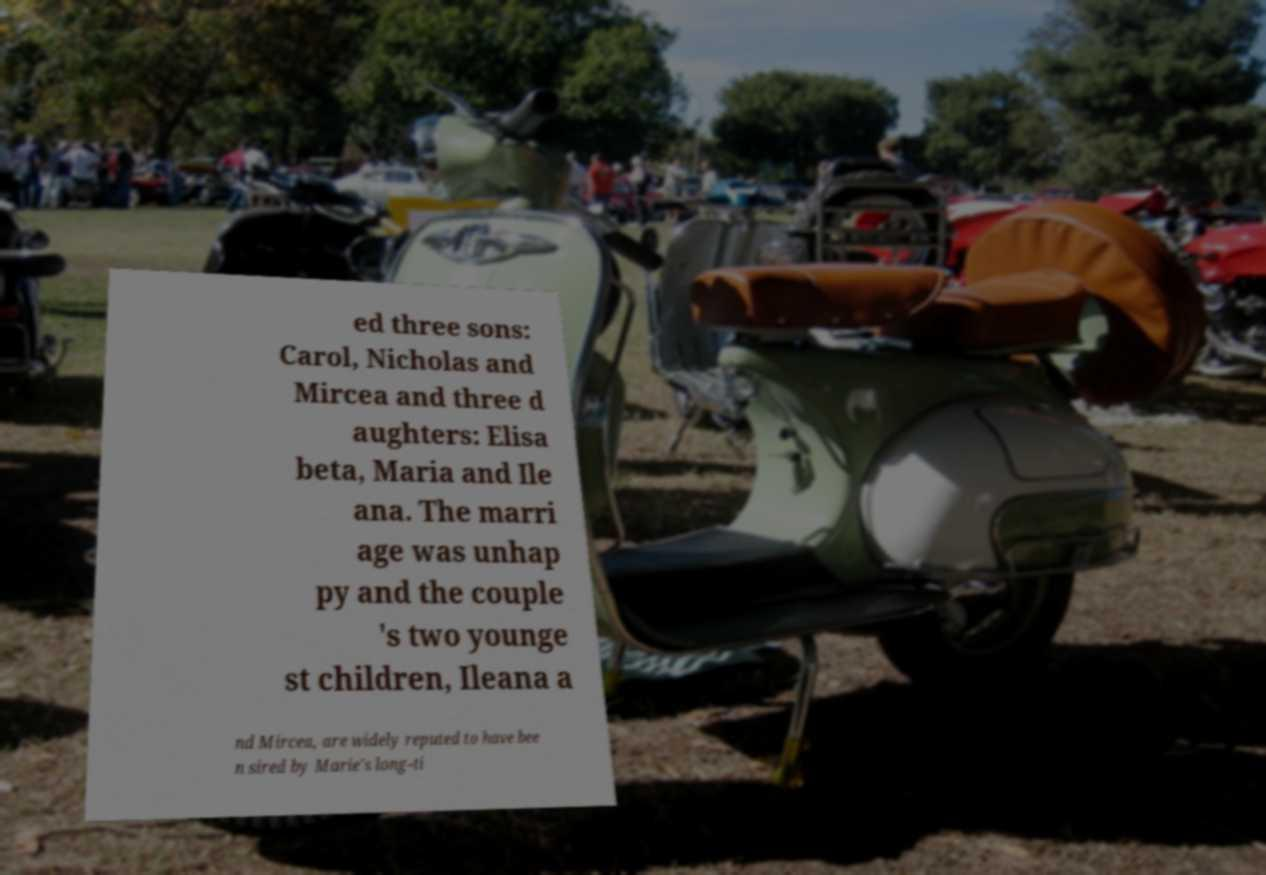Can you accurately transcribe the text from the provided image for me? ed three sons: Carol, Nicholas and Mircea and three d aughters: Elisa beta, Maria and Ile ana. The marri age was unhap py and the couple 's two younge st children, Ileana a nd Mircea, are widely reputed to have bee n sired by Marie's long-ti 